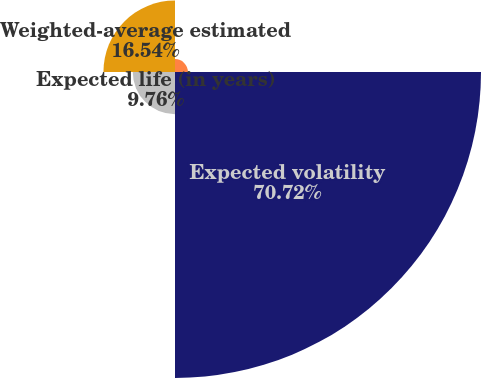Convert chart to OTSL. <chart><loc_0><loc_0><loc_500><loc_500><pie_chart><fcel>Risk-free interest rate<fcel>Expected volatility<fcel>Expected life (in years)<fcel>Weighted-average estimated<nl><fcel>2.98%<fcel>70.73%<fcel>9.76%<fcel>16.54%<nl></chart> 